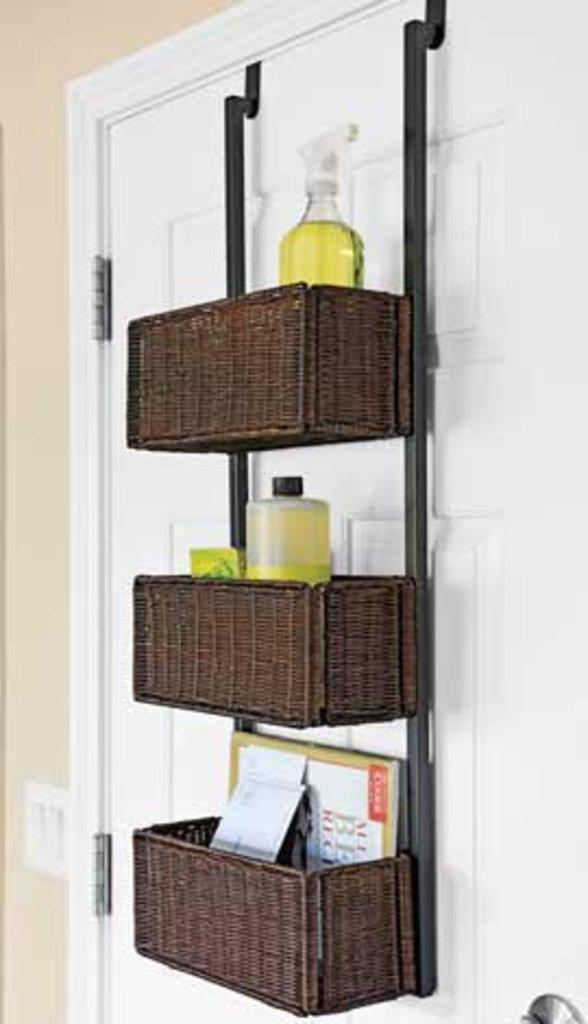What is located in the foreground of the image? There is a wall, a cupboard, and a stand with bottles and books in the foreground of the image. What type of room might the image be taken in? The image is likely taken in a room, as it contains furniture and objects typically found indoors. What type of popcorn is being used to create the coil on the tooth in the image? There is no popcorn, coil, or tooth present in the image. 